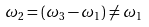<formula> <loc_0><loc_0><loc_500><loc_500>\omega _ { 2 } & = ( \omega _ { 3 } - \omega _ { 1 } ) \ne \omega _ { 1 }</formula> 